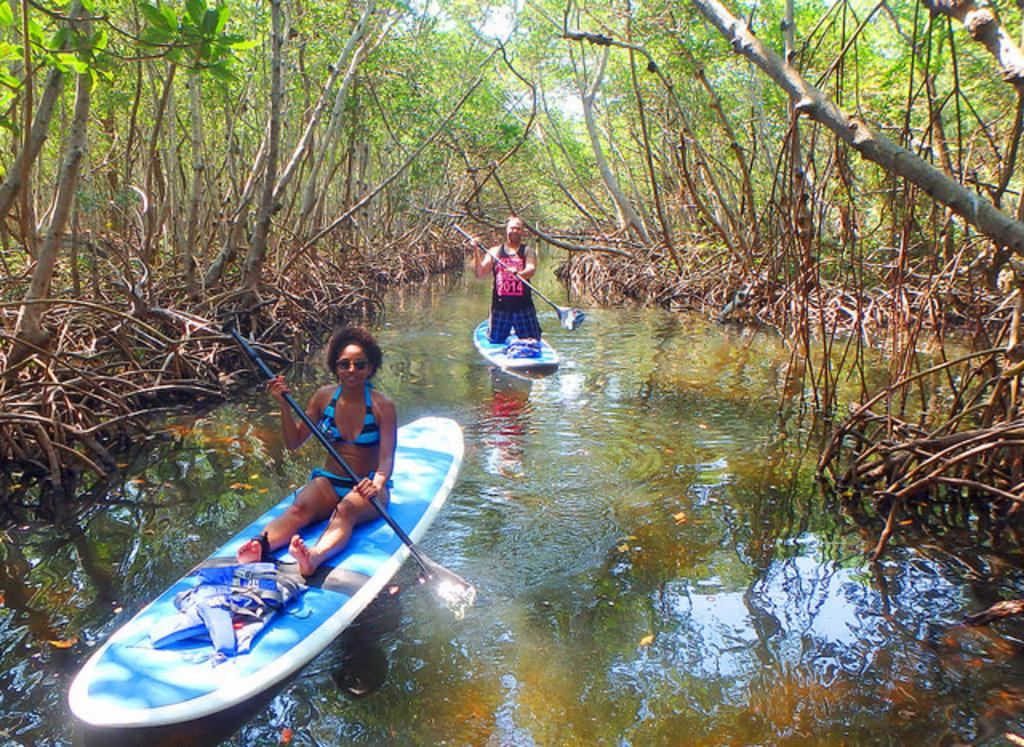How many people are in the image? There are two people in the image. What are the people doing in the image? The people are on a boat and holding paddles. What is visible in the image besides the people and the boat? There is water, trees, and the sky visible in the image. What grade is the tree in the image? There is no tree mentioned in the image; it only mentions trees in general. What type of motion is the boat experiencing in the image? The image does not show any motion of the boat; it only shows a static scene. 